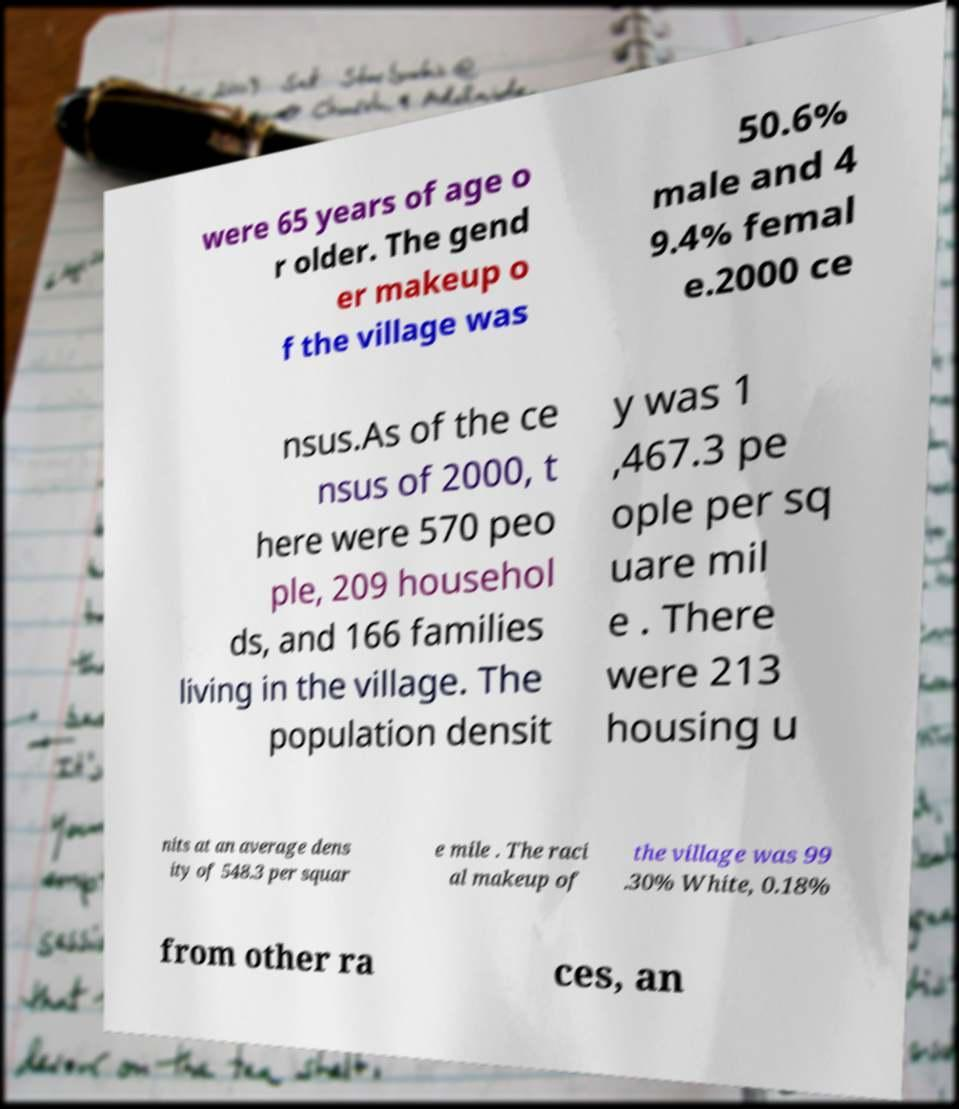I need the written content from this picture converted into text. Can you do that? were 65 years of age o r older. The gend er makeup o f the village was 50.6% male and 4 9.4% femal e.2000 ce nsus.As of the ce nsus of 2000, t here were 570 peo ple, 209 househol ds, and 166 families living in the village. The population densit y was 1 ,467.3 pe ople per sq uare mil e . There were 213 housing u nits at an average dens ity of 548.3 per squar e mile . The raci al makeup of the village was 99 .30% White, 0.18% from other ra ces, an 